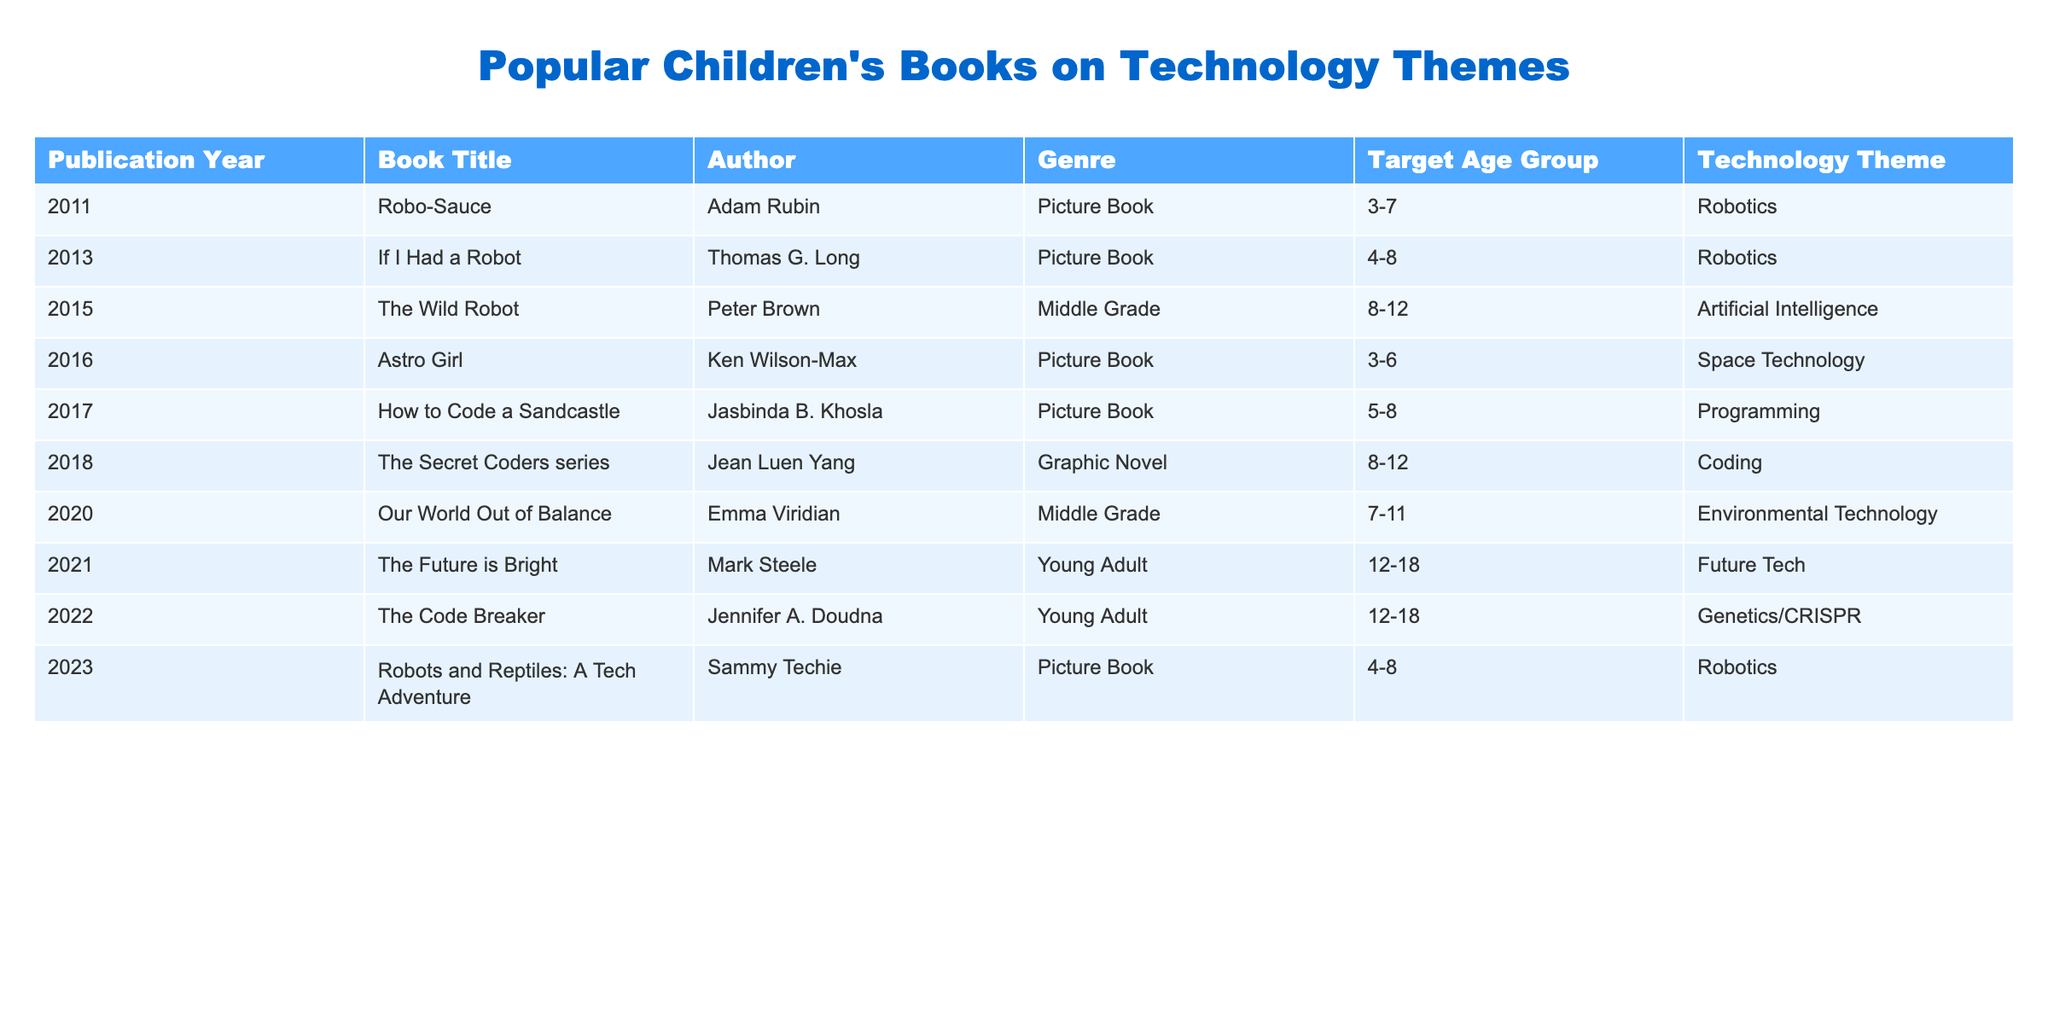What is the title of the book published in 2021? By scanning the table, I locate the row for 2021 and find that the title of the book listed for that year is "The Future is Bright."
Answer: The Future is Bright Which author wrote a book focused on space technology? Looking through the table, I find that "Astro Girl," which focuses on space technology, is authored by Ken Wilson-Max.
Answer: Ken Wilson-Max How many books are listed in total in the table? Counting the rows in the table, there are 10 books included.
Answer: 10 What is the technology theme of the book "The Wild Robot"? Referring to the entry for "The Wild Robot," I can see that its technology theme is artificial intelligence.
Answer: Artificial Intelligence In what year was the first book on robotics published? By reviewing the publication years in the table, I note that the first book on robotics, "Robo-Sauce," was published in 2011.
Answer: 2011 How many books target the age group 3-7? I look at the age group information for each book and find that there are 4 books targeting the age group 3-7.
Answer: 4 Is "The Secret Coders series" a middle-grade book? Reviewing the table, it indicates that "The Secret Coders series" is categorized as a graphic novel, not a middle-grade book, so the answer is no.
Answer: No Which book has a technology theme related to genetics? By checking the technology themes listed, I find that "The Code Breaker" has a theme focused on genetics/CRISPR.
Answer: The Code Breaker What is the most recent publication year for a book listed in the table? I look through the publication years provided and see that the most recent year mentioned is 2023.
Answer: 2023 How many books in the table focus on programming or coding themes? I identify the books with technology themes of programming and coding. "How to Code a Sandcastle" and "The Secret Coders series" fit this criterion, giving a total of 2 books.
Answer: 2 